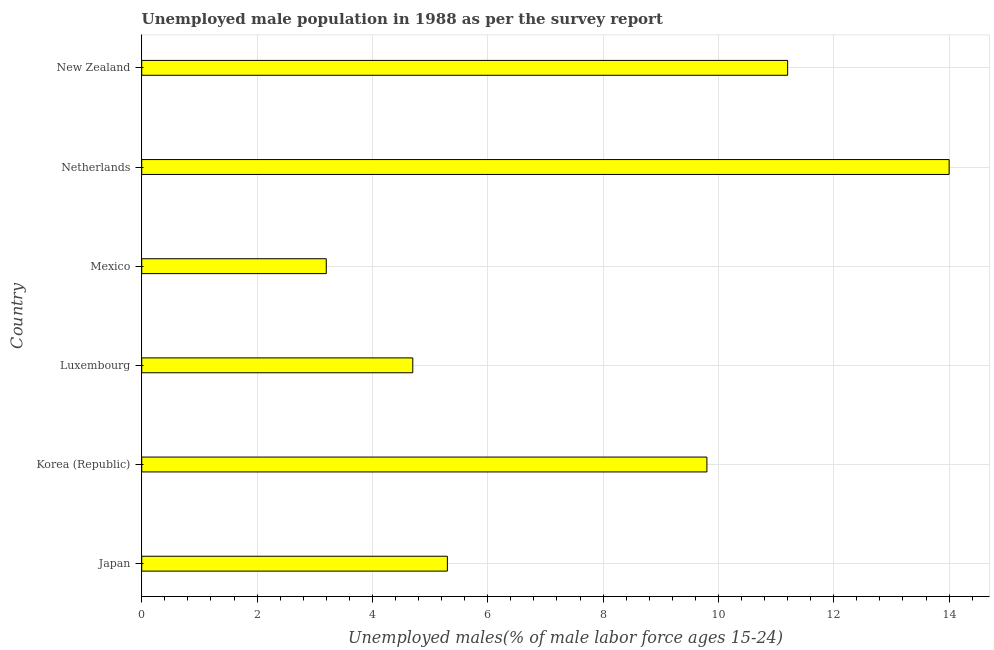What is the title of the graph?
Keep it short and to the point. Unemployed male population in 1988 as per the survey report. What is the label or title of the X-axis?
Provide a succinct answer. Unemployed males(% of male labor force ages 15-24). What is the label or title of the Y-axis?
Give a very brief answer. Country. What is the unemployed male youth in Luxembourg?
Ensure brevity in your answer.  4.7. Across all countries, what is the minimum unemployed male youth?
Provide a succinct answer. 3.2. What is the sum of the unemployed male youth?
Give a very brief answer. 48.2. What is the difference between the unemployed male youth in Luxembourg and New Zealand?
Your answer should be compact. -6.5. What is the average unemployed male youth per country?
Your answer should be compact. 8.03. What is the median unemployed male youth?
Your answer should be compact. 7.55. In how many countries, is the unemployed male youth greater than 11.2 %?
Offer a terse response. 1. What is the ratio of the unemployed male youth in Korea (Republic) to that in Mexico?
Provide a short and direct response. 3.06. Is the unemployed male youth in Netherlands less than that in New Zealand?
Offer a terse response. No. Is the sum of the unemployed male youth in Korea (Republic) and Mexico greater than the maximum unemployed male youth across all countries?
Give a very brief answer. No. What is the difference between the highest and the lowest unemployed male youth?
Offer a very short reply. 10.8. In how many countries, is the unemployed male youth greater than the average unemployed male youth taken over all countries?
Give a very brief answer. 3. How many bars are there?
Your answer should be compact. 6. What is the Unemployed males(% of male labor force ages 15-24) of Japan?
Your answer should be very brief. 5.3. What is the Unemployed males(% of male labor force ages 15-24) in Korea (Republic)?
Keep it short and to the point. 9.8. What is the Unemployed males(% of male labor force ages 15-24) of Luxembourg?
Provide a short and direct response. 4.7. What is the Unemployed males(% of male labor force ages 15-24) of Mexico?
Keep it short and to the point. 3.2. What is the Unemployed males(% of male labor force ages 15-24) in Netherlands?
Provide a short and direct response. 14. What is the Unemployed males(% of male labor force ages 15-24) of New Zealand?
Keep it short and to the point. 11.2. What is the difference between the Unemployed males(% of male labor force ages 15-24) in Japan and Korea (Republic)?
Your answer should be very brief. -4.5. What is the difference between the Unemployed males(% of male labor force ages 15-24) in Japan and Luxembourg?
Keep it short and to the point. 0.6. What is the difference between the Unemployed males(% of male labor force ages 15-24) in Japan and Netherlands?
Provide a succinct answer. -8.7. What is the difference between the Unemployed males(% of male labor force ages 15-24) in Korea (Republic) and Luxembourg?
Give a very brief answer. 5.1. What is the difference between the Unemployed males(% of male labor force ages 15-24) in Korea (Republic) and Mexico?
Provide a succinct answer. 6.6. What is the difference between the Unemployed males(% of male labor force ages 15-24) in Luxembourg and Mexico?
Make the answer very short. 1.5. What is the difference between the Unemployed males(% of male labor force ages 15-24) in Luxembourg and Netherlands?
Provide a succinct answer. -9.3. What is the difference between the Unemployed males(% of male labor force ages 15-24) in Mexico and New Zealand?
Offer a very short reply. -8. What is the ratio of the Unemployed males(% of male labor force ages 15-24) in Japan to that in Korea (Republic)?
Ensure brevity in your answer.  0.54. What is the ratio of the Unemployed males(% of male labor force ages 15-24) in Japan to that in Luxembourg?
Your answer should be compact. 1.13. What is the ratio of the Unemployed males(% of male labor force ages 15-24) in Japan to that in Mexico?
Make the answer very short. 1.66. What is the ratio of the Unemployed males(% of male labor force ages 15-24) in Japan to that in Netherlands?
Ensure brevity in your answer.  0.38. What is the ratio of the Unemployed males(% of male labor force ages 15-24) in Japan to that in New Zealand?
Provide a short and direct response. 0.47. What is the ratio of the Unemployed males(% of male labor force ages 15-24) in Korea (Republic) to that in Luxembourg?
Your response must be concise. 2.08. What is the ratio of the Unemployed males(% of male labor force ages 15-24) in Korea (Republic) to that in Mexico?
Your response must be concise. 3.06. What is the ratio of the Unemployed males(% of male labor force ages 15-24) in Korea (Republic) to that in Netherlands?
Your answer should be compact. 0.7. What is the ratio of the Unemployed males(% of male labor force ages 15-24) in Korea (Republic) to that in New Zealand?
Offer a terse response. 0.88. What is the ratio of the Unemployed males(% of male labor force ages 15-24) in Luxembourg to that in Mexico?
Your response must be concise. 1.47. What is the ratio of the Unemployed males(% of male labor force ages 15-24) in Luxembourg to that in Netherlands?
Ensure brevity in your answer.  0.34. What is the ratio of the Unemployed males(% of male labor force ages 15-24) in Luxembourg to that in New Zealand?
Keep it short and to the point. 0.42. What is the ratio of the Unemployed males(% of male labor force ages 15-24) in Mexico to that in Netherlands?
Provide a short and direct response. 0.23. What is the ratio of the Unemployed males(% of male labor force ages 15-24) in Mexico to that in New Zealand?
Your response must be concise. 0.29. What is the ratio of the Unemployed males(% of male labor force ages 15-24) in Netherlands to that in New Zealand?
Keep it short and to the point. 1.25. 